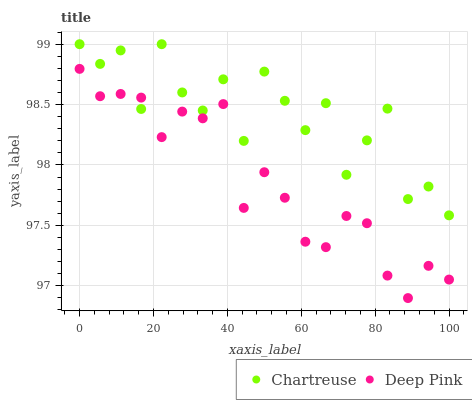Does Deep Pink have the minimum area under the curve?
Answer yes or no. Yes. Does Chartreuse have the maximum area under the curve?
Answer yes or no. Yes. Does Deep Pink have the maximum area under the curve?
Answer yes or no. No. Is Deep Pink the smoothest?
Answer yes or no. Yes. Is Chartreuse the roughest?
Answer yes or no. Yes. Is Deep Pink the roughest?
Answer yes or no. No. Does Deep Pink have the lowest value?
Answer yes or no. Yes. Does Chartreuse have the highest value?
Answer yes or no. Yes. Does Deep Pink have the highest value?
Answer yes or no. No. Does Deep Pink intersect Chartreuse?
Answer yes or no. Yes. Is Deep Pink less than Chartreuse?
Answer yes or no. No. Is Deep Pink greater than Chartreuse?
Answer yes or no. No. 